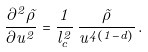Convert formula to latex. <formula><loc_0><loc_0><loc_500><loc_500>\frac { \partial ^ { 2 } \tilde { \rho } } { \partial u ^ { 2 } } = \frac { 1 } { l _ { c } ^ { 2 } } \, \frac { \tilde { \rho } } { u ^ { 4 ( 1 - d ) } } \, .</formula> 